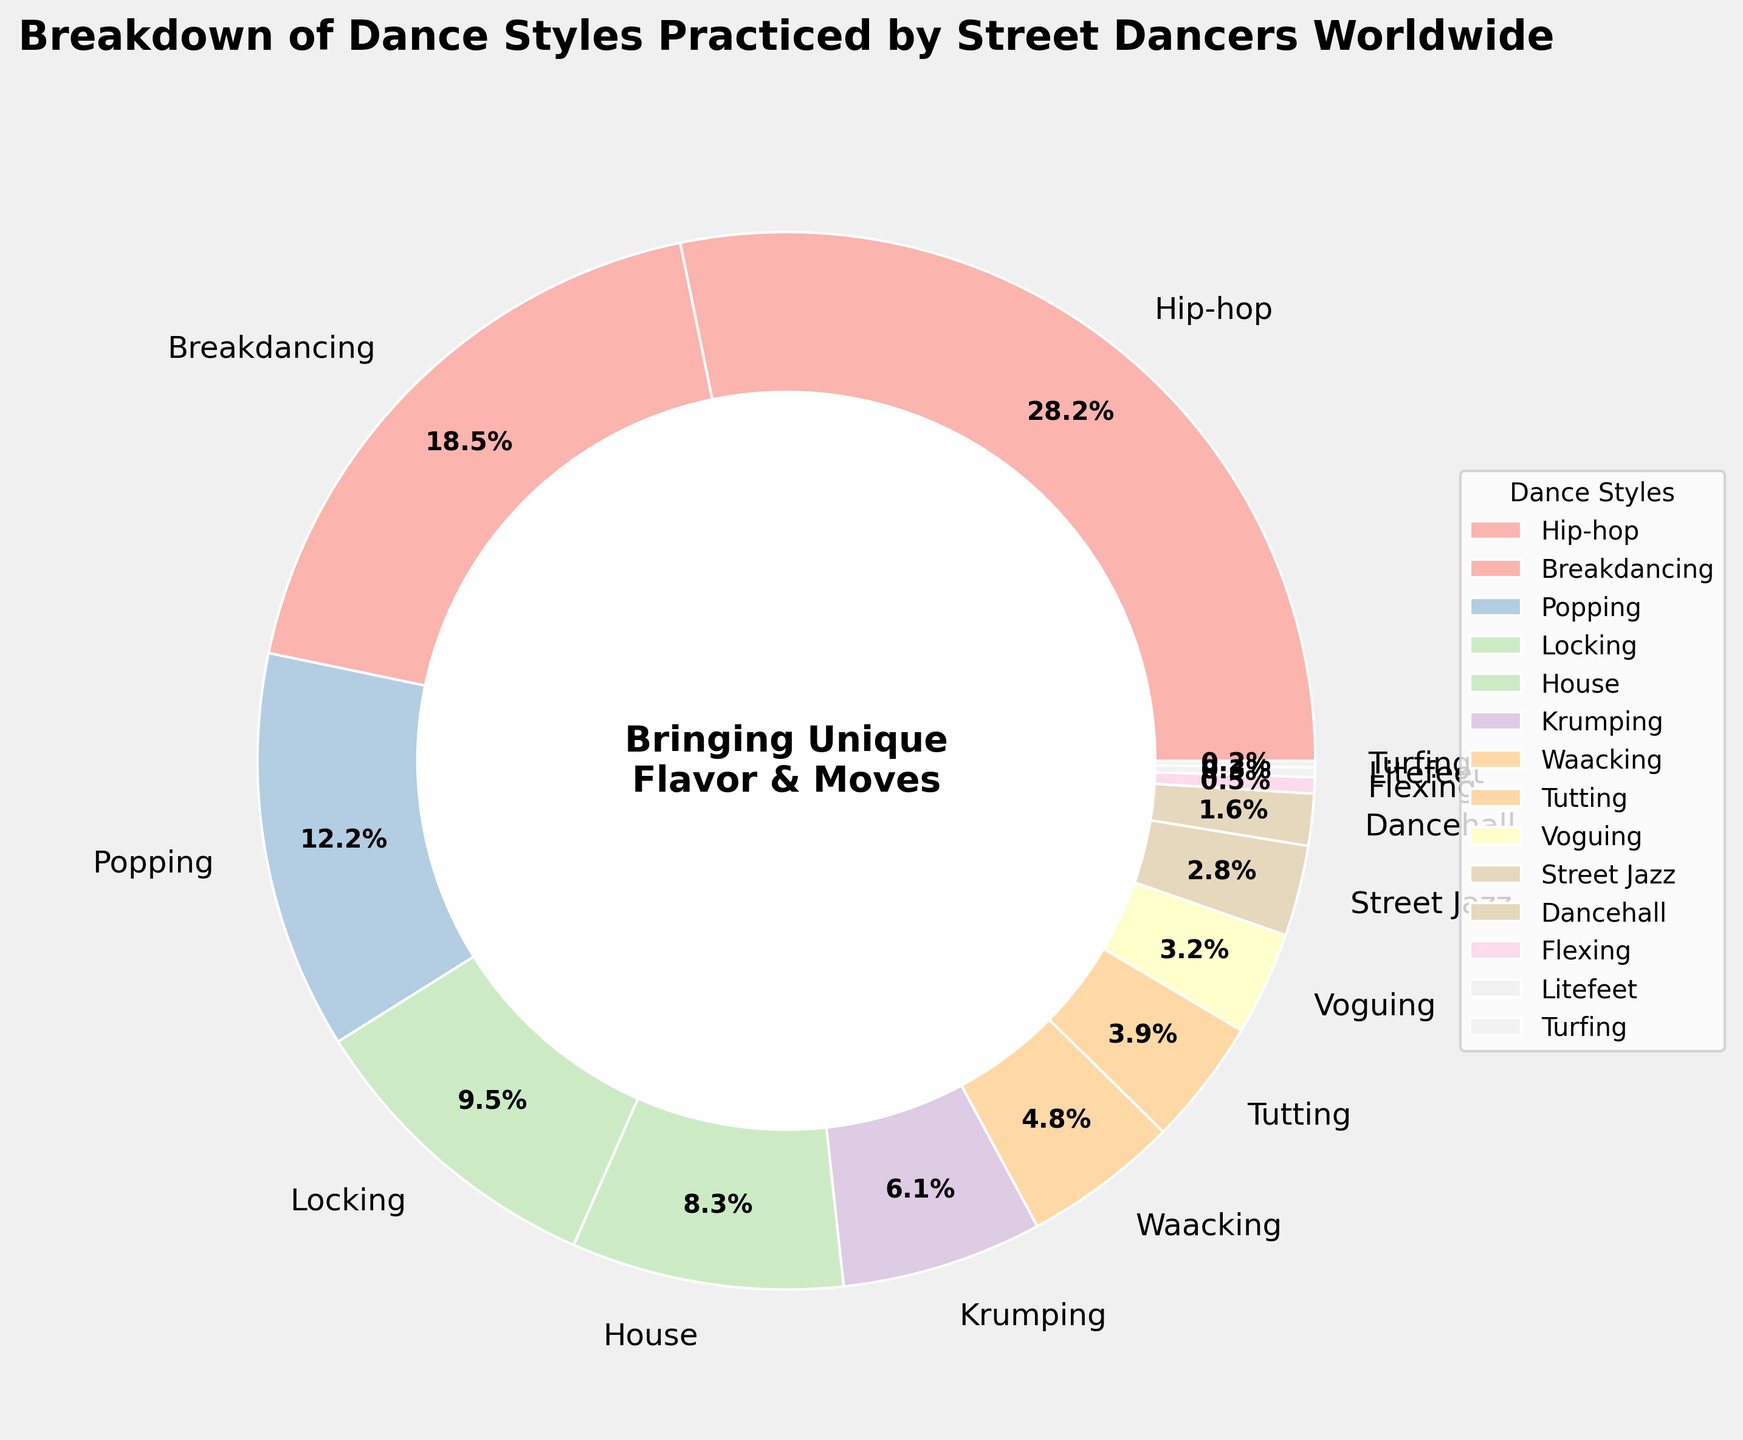What are the two most practiced dance styles by street dancers worldwide? By observing the pie chart, the largest segments represent Hip-hop and Breakdancing, with respective percentages of 28.5% and 18.7%.
Answer: Hip-hop and Breakdancing What is the combined percentage of dancers practicing Locking and Popping? From the pie chart, Locking is 9.6% and Popping is 12.3%. Adding these percentages gives us 9.6 + 12.3 = 21.9%.
Answer: 21.9% How does the percentage of dancers practicing House compare to those practicing Krumping? House has a percentage of 8.4%, while Krumping is at 6.2%. Therefore, House is practiced by a higher percentage of dancers compared to Krumping.
Answer: House > Krumping Among Voguing, Street Jazz, and Dancehall, which dance style has the smallest percentage of practitioners, and what is the percentage? From the pie chart, Voguing is 3.2%, Street Jazz is 2.8%, and Dancehall is 1.6%. Dancehall has the smallest percentage among these three.
Answer: Dancehall, 1.6% What percentage of street dancers practice dance styles that individually account for less than 4%? The dance styles under 4% are Tutting (3.9%), Voguing (3.2%), Street Jazz (2.8%), Dancehall (1.6%), Flexing (0.5%), Litefeet (0.3%), and Turfing (0.2%). Adding these up gives 3.9 + 3.2 + 2.8 + 1.6 + 0.5 + 0.3 + 0.2 = 12.5%.
Answer: 12.5% Which dance style segment has a visually distinguishable makeover with a brighter color and is positioned on the outer left side of the pie? By visually inspecting the pie chart, Hip-hop, the largest segment, stands out with a brighter pastel color and is positioned on the outer left side of the pie chart.
Answer: Hip-hop What is the difference in the percentage of dancers practicing Waacking compared to Voguing? Waacking is 4.8% and Voguing is 3.2%. The difference is 4.8 - 3.2 = 1.6%.
Answer: 1.6% If you combine Popping, Locking, and House, what percentage of street dancers practice these styles? The percentages for Popping (12.3%), Locking (9.6%), and House (8.4%) add up to 12.3 + 9.6 + 8.4 = 30.3%.
Answer: 30.3% 